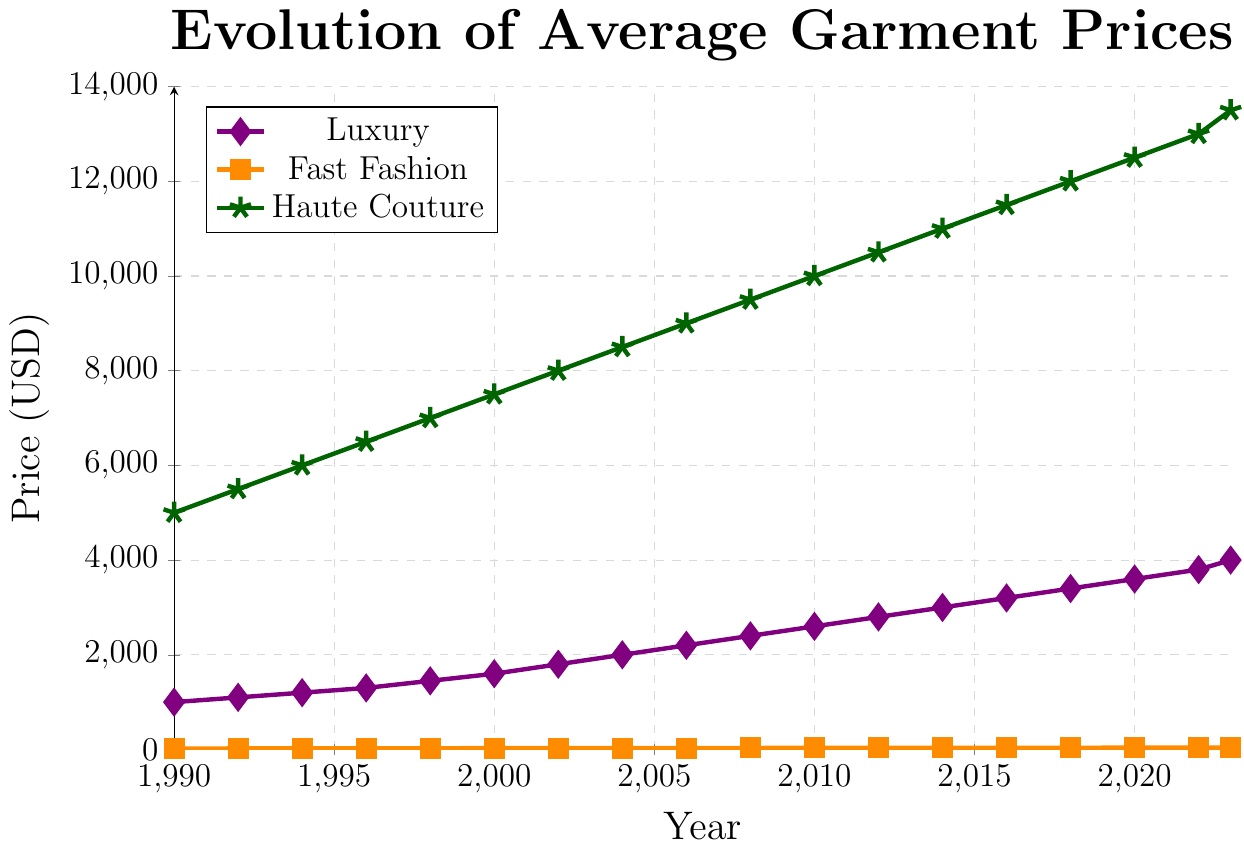What's the trend in the average price of luxury garments from 1990 to 2023? To identify the trend, observe the luxury line in the plot, which shows prices consistently increasing from 1000 USD in 1990 to 4000 USD in 2023.
Answer: Consistently increasing Which fashion segment had the highest average price in 2008? Look at the data points for each segment in 2008 on the chart. Fast Fashion is around 32 USD, Luxury is around 2400 USD, and Haute Couture is around 9500 USD.
Answer: Haute Couture In which year did average garment prices in the Fast Fashion segment reach $30? Trace the Fast Fashion line and locate the year when the price first hits 30. The data indicates it occurred in 2004.
Answer: 2004 How much did the price of Haute Couture garments increase from 1990 to 2023? Subtract the initial value in 1990 (5000 USD) from the value in 2023 (13500 USD). The price increased by 13500 - 5000 = 8500 USD.
Answer: 8500 USD Which segment shows the steepest increase in prices over time? Compare the slopes of the lines for each segment. Haute Couture demonstrates the steepest incline, followed by Luxury, and then Fast Fashion.
Answer: Haute Couture How do the price trends of Luxury and Fast Fashion compare between 1990 and 2000? Examine the trends within this decade. Luxury prices increased from 1000 USD to 1600 USD, while Fast Fashion prices rose from 20 USD to 28 USD. This shows a similar upward trend, albeit differently scaled.
Answer: Both increased What's the difference in the average price of Haute Couture garments between 2014 and 2018? Locate the prices for Haute Couture in 2014 (11000 USD) and 2018 (12000 USD). The difference is 12000 - 11000 = 1000 USD.
Answer: 1000 USD In which year did Luxury garments' prices surpass 2000 USD? Follow the Luxury line and find the year when the price first crossed 2000 USD, which was in 2004.
Answer: 2004 Are the price changes in Fast Fashion more gradual compared to Luxury and Haute Couture? Observe the slope of the Fast Fashion line, which is relatively flatter compared to the steeper slopes of the Luxury and Haute Couture lines.
Answer: Yes 